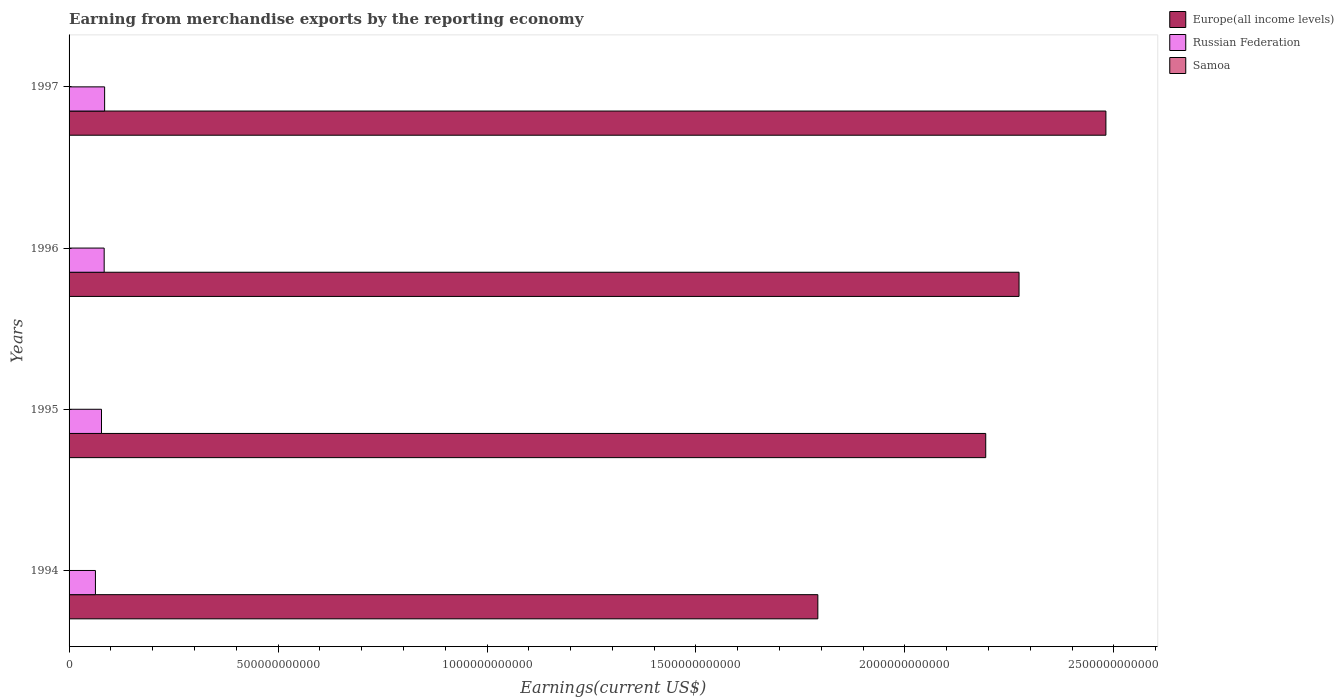How many groups of bars are there?
Give a very brief answer. 4. How many bars are there on the 3rd tick from the bottom?
Offer a terse response. 3. What is the label of the 2nd group of bars from the top?
Give a very brief answer. 1996. In how many cases, is the number of bars for a given year not equal to the number of legend labels?
Make the answer very short. 0. What is the amount earned from merchandise exports in Europe(all income levels) in 1995?
Ensure brevity in your answer.  2.19e+12. Across all years, what is the maximum amount earned from merchandise exports in Samoa?
Ensure brevity in your answer.  6.48e+07. Across all years, what is the minimum amount earned from merchandise exports in Samoa?
Offer a terse response. 3.98e+06. In which year was the amount earned from merchandise exports in Samoa minimum?
Offer a terse response. 1994. What is the total amount earned from merchandise exports in Samoa in the graph?
Your answer should be compact. 1.94e+08. What is the difference between the amount earned from merchandise exports in Russian Federation in 1994 and that in 1997?
Offer a terse response. -2.20e+1. What is the difference between the amount earned from merchandise exports in Europe(all income levels) in 1994 and the amount earned from merchandise exports in Samoa in 1995?
Keep it short and to the point. 1.79e+12. What is the average amount earned from merchandise exports in Russian Federation per year?
Your answer should be compact. 7.74e+1. In the year 1996, what is the difference between the amount earned from merchandise exports in Europe(all income levels) and amount earned from merchandise exports in Russian Federation?
Your response must be concise. 2.19e+12. In how many years, is the amount earned from merchandise exports in Russian Federation greater than 300000000000 US$?
Ensure brevity in your answer.  0. What is the ratio of the amount earned from merchandise exports in Europe(all income levels) in 1994 to that in 1997?
Your answer should be very brief. 0.72. Is the amount earned from merchandise exports in Europe(all income levels) in 1994 less than that in 1995?
Ensure brevity in your answer.  Yes. Is the difference between the amount earned from merchandise exports in Europe(all income levels) in 1995 and 1996 greater than the difference between the amount earned from merchandise exports in Russian Federation in 1995 and 1996?
Your response must be concise. No. What is the difference between the highest and the second highest amount earned from merchandise exports in Samoa?
Give a very brief answer. 6.89e+04. What is the difference between the highest and the lowest amount earned from merchandise exports in Russian Federation?
Ensure brevity in your answer.  2.20e+1. Is the sum of the amount earned from merchandise exports in Samoa in 1994 and 1997 greater than the maximum amount earned from merchandise exports in Europe(all income levels) across all years?
Your answer should be compact. No. What does the 2nd bar from the top in 1995 represents?
Provide a short and direct response. Russian Federation. What does the 3rd bar from the bottom in 1997 represents?
Make the answer very short. Samoa. How many bars are there?
Your answer should be compact. 12. Are all the bars in the graph horizontal?
Keep it short and to the point. Yes. What is the difference between two consecutive major ticks on the X-axis?
Offer a very short reply. 5.00e+11. Are the values on the major ticks of X-axis written in scientific E-notation?
Your answer should be compact. No. Does the graph contain any zero values?
Your response must be concise. No. Where does the legend appear in the graph?
Keep it short and to the point. Top right. How are the legend labels stacked?
Give a very brief answer. Vertical. What is the title of the graph?
Offer a terse response. Earning from merchandise exports by the reporting economy. What is the label or title of the X-axis?
Your answer should be very brief. Earnings(current US$). What is the Earnings(current US$) in Europe(all income levels) in 1994?
Ensure brevity in your answer.  1.79e+12. What is the Earnings(current US$) in Russian Federation in 1994?
Provide a succinct answer. 6.31e+1. What is the Earnings(current US$) of Samoa in 1994?
Your response must be concise. 3.98e+06. What is the Earnings(current US$) of Europe(all income levels) in 1995?
Offer a terse response. 2.19e+12. What is the Earnings(current US$) of Russian Federation in 1995?
Your answer should be very brief. 7.76e+1. What is the Earnings(current US$) of Samoa in 1995?
Your answer should be very brief. 6.09e+07. What is the Earnings(current US$) of Europe(all income levels) in 1996?
Keep it short and to the point. 2.27e+12. What is the Earnings(current US$) of Russian Federation in 1996?
Offer a very short reply. 8.40e+1. What is the Earnings(current US$) of Samoa in 1996?
Keep it short and to the point. 6.48e+07. What is the Earnings(current US$) in Europe(all income levels) in 1997?
Provide a short and direct response. 2.48e+12. What is the Earnings(current US$) in Russian Federation in 1997?
Your response must be concise. 8.51e+1. What is the Earnings(current US$) in Samoa in 1997?
Offer a terse response. 6.47e+07. Across all years, what is the maximum Earnings(current US$) of Europe(all income levels)?
Make the answer very short. 2.48e+12. Across all years, what is the maximum Earnings(current US$) of Russian Federation?
Your answer should be very brief. 8.51e+1. Across all years, what is the maximum Earnings(current US$) of Samoa?
Your response must be concise. 6.48e+07. Across all years, what is the minimum Earnings(current US$) of Europe(all income levels)?
Offer a terse response. 1.79e+12. Across all years, what is the minimum Earnings(current US$) in Russian Federation?
Your answer should be compact. 6.31e+1. Across all years, what is the minimum Earnings(current US$) of Samoa?
Your answer should be compact. 3.98e+06. What is the total Earnings(current US$) of Europe(all income levels) in the graph?
Your answer should be very brief. 8.74e+12. What is the total Earnings(current US$) in Russian Federation in the graph?
Give a very brief answer. 3.10e+11. What is the total Earnings(current US$) in Samoa in the graph?
Provide a succinct answer. 1.94e+08. What is the difference between the Earnings(current US$) of Europe(all income levels) in 1994 and that in 1995?
Make the answer very short. -4.02e+11. What is the difference between the Earnings(current US$) of Russian Federation in 1994 and that in 1995?
Provide a succinct answer. -1.45e+1. What is the difference between the Earnings(current US$) of Samoa in 1994 and that in 1995?
Ensure brevity in your answer.  -5.69e+07. What is the difference between the Earnings(current US$) in Europe(all income levels) in 1994 and that in 1996?
Make the answer very short. -4.81e+11. What is the difference between the Earnings(current US$) of Russian Federation in 1994 and that in 1996?
Your answer should be very brief. -2.09e+1. What is the difference between the Earnings(current US$) of Samoa in 1994 and that in 1996?
Your response must be concise. -6.08e+07. What is the difference between the Earnings(current US$) in Europe(all income levels) in 1994 and that in 1997?
Ensure brevity in your answer.  -6.89e+11. What is the difference between the Earnings(current US$) in Russian Federation in 1994 and that in 1997?
Your answer should be compact. -2.20e+1. What is the difference between the Earnings(current US$) of Samoa in 1994 and that in 1997?
Offer a very short reply. -6.07e+07. What is the difference between the Earnings(current US$) of Europe(all income levels) in 1995 and that in 1996?
Your answer should be very brief. -7.97e+1. What is the difference between the Earnings(current US$) of Russian Federation in 1995 and that in 1996?
Make the answer very short. -6.38e+09. What is the difference between the Earnings(current US$) in Samoa in 1995 and that in 1996?
Provide a short and direct response. -3.85e+06. What is the difference between the Earnings(current US$) in Europe(all income levels) in 1995 and that in 1997?
Ensure brevity in your answer.  -2.88e+11. What is the difference between the Earnings(current US$) of Russian Federation in 1995 and that in 1997?
Your answer should be compact. -7.48e+09. What is the difference between the Earnings(current US$) in Samoa in 1995 and that in 1997?
Provide a short and direct response. -3.79e+06. What is the difference between the Earnings(current US$) of Europe(all income levels) in 1996 and that in 1997?
Keep it short and to the point. -2.08e+11. What is the difference between the Earnings(current US$) of Russian Federation in 1996 and that in 1997?
Keep it short and to the point. -1.10e+09. What is the difference between the Earnings(current US$) of Samoa in 1996 and that in 1997?
Offer a very short reply. 6.89e+04. What is the difference between the Earnings(current US$) of Europe(all income levels) in 1994 and the Earnings(current US$) of Russian Federation in 1995?
Your answer should be very brief. 1.71e+12. What is the difference between the Earnings(current US$) of Europe(all income levels) in 1994 and the Earnings(current US$) of Samoa in 1995?
Offer a terse response. 1.79e+12. What is the difference between the Earnings(current US$) of Russian Federation in 1994 and the Earnings(current US$) of Samoa in 1995?
Your answer should be very brief. 6.30e+1. What is the difference between the Earnings(current US$) of Europe(all income levels) in 1994 and the Earnings(current US$) of Russian Federation in 1996?
Make the answer very short. 1.71e+12. What is the difference between the Earnings(current US$) in Europe(all income levels) in 1994 and the Earnings(current US$) in Samoa in 1996?
Your answer should be compact. 1.79e+12. What is the difference between the Earnings(current US$) in Russian Federation in 1994 and the Earnings(current US$) in Samoa in 1996?
Offer a terse response. 6.30e+1. What is the difference between the Earnings(current US$) of Europe(all income levels) in 1994 and the Earnings(current US$) of Russian Federation in 1997?
Ensure brevity in your answer.  1.71e+12. What is the difference between the Earnings(current US$) in Europe(all income levels) in 1994 and the Earnings(current US$) in Samoa in 1997?
Your answer should be very brief. 1.79e+12. What is the difference between the Earnings(current US$) in Russian Federation in 1994 and the Earnings(current US$) in Samoa in 1997?
Your answer should be very brief. 6.30e+1. What is the difference between the Earnings(current US$) of Europe(all income levels) in 1995 and the Earnings(current US$) of Russian Federation in 1996?
Your response must be concise. 2.11e+12. What is the difference between the Earnings(current US$) of Europe(all income levels) in 1995 and the Earnings(current US$) of Samoa in 1996?
Provide a succinct answer. 2.19e+12. What is the difference between the Earnings(current US$) in Russian Federation in 1995 and the Earnings(current US$) in Samoa in 1996?
Your answer should be compact. 7.75e+1. What is the difference between the Earnings(current US$) of Europe(all income levels) in 1995 and the Earnings(current US$) of Russian Federation in 1997?
Offer a terse response. 2.11e+12. What is the difference between the Earnings(current US$) of Europe(all income levels) in 1995 and the Earnings(current US$) of Samoa in 1997?
Offer a terse response. 2.19e+12. What is the difference between the Earnings(current US$) in Russian Federation in 1995 and the Earnings(current US$) in Samoa in 1997?
Ensure brevity in your answer.  7.75e+1. What is the difference between the Earnings(current US$) in Europe(all income levels) in 1996 and the Earnings(current US$) in Russian Federation in 1997?
Provide a succinct answer. 2.19e+12. What is the difference between the Earnings(current US$) of Europe(all income levels) in 1996 and the Earnings(current US$) of Samoa in 1997?
Provide a short and direct response. 2.27e+12. What is the difference between the Earnings(current US$) of Russian Federation in 1996 and the Earnings(current US$) of Samoa in 1997?
Make the answer very short. 8.39e+1. What is the average Earnings(current US$) of Europe(all income levels) per year?
Offer a terse response. 2.18e+12. What is the average Earnings(current US$) of Russian Federation per year?
Offer a very short reply. 7.74e+1. What is the average Earnings(current US$) in Samoa per year?
Ensure brevity in your answer.  4.86e+07. In the year 1994, what is the difference between the Earnings(current US$) in Europe(all income levels) and Earnings(current US$) in Russian Federation?
Your answer should be compact. 1.73e+12. In the year 1994, what is the difference between the Earnings(current US$) in Europe(all income levels) and Earnings(current US$) in Samoa?
Make the answer very short. 1.79e+12. In the year 1994, what is the difference between the Earnings(current US$) of Russian Federation and Earnings(current US$) of Samoa?
Keep it short and to the point. 6.31e+1. In the year 1995, what is the difference between the Earnings(current US$) of Europe(all income levels) and Earnings(current US$) of Russian Federation?
Keep it short and to the point. 2.12e+12. In the year 1995, what is the difference between the Earnings(current US$) of Europe(all income levels) and Earnings(current US$) of Samoa?
Your response must be concise. 2.19e+12. In the year 1995, what is the difference between the Earnings(current US$) in Russian Federation and Earnings(current US$) in Samoa?
Offer a terse response. 7.75e+1. In the year 1996, what is the difference between the Earnings(current US$) of Europe(all income levels) and Earnings(current US$) of Russian Federation?
Your answer should be very brief. 2.19e+12. In the year 1996, what is the difference between the Earnings(current US$) in Europe(all income levels) and Earnings(current US$) in Samoa?
Give a very brief answer. 2.27e+12. In the year 1996, what is the difference between the Earnings(current US$) of Russian Federation and Earnings(current US$) of Samoa?
Make the answer very short. 8.39e+1. In the year 1997, what is the difference between the Earnings(current US$) in Europe(all income levels) and Earnings(current US$) in Russian Federation?
Your response must be concise. 2.40e+12. In the year 1997, what is the difference between the Earnings(current US$) of Europe(all income levels) and Earnings(current US$) of Samoa?
Keep it short and to the point. 2.48e+12. In the year 1997, what is the difference between the Earnings(current US$) in Russian Federation and Earnings(current US$) in Samoa?
Keep it short and to the point. 8.50e+1. What is the ratio of the Earnings(current US$) in Europe(all income levels) in 1994 to that in 1995?
Provide a short and direct response. 0.82. What is the ratio of the Earnings(current US$) in Russian Federation in 1994 to that in 1995?
Your response must be concise. 0.81. What is the ratio of the Earnings(current US$) in Samoa in 1994 to that in 1995?
Keep it short and to the point. 0.07. What is the ratio of the Earnings(current US$) of Europe(all income levels) in 1994 to that in 1996?
Provide a succinct answer. 0.79. What is the ratio of the Earnings(current US$) in Russian Federation in 1994 to that in 1996?
Offer a terse response. 0.75. What is the ratio of the Earnings(current US$) in Samoa in 1994 to that in 1996?
Your answer should be very brief. 0.06. What is the ratio of the Earnings(current US$) in Europe(all income levels) in 1994 to that in 1997?
Ensure brevity in your answer.  0.72. What is the ratio of the Earnings(current US$) of Russian Federation in 1994 to that in 1997?
Provide a succinct answer. 0.74. What is the ratio of the Earnings(current US$) in Samoa in 1994 to that in 1997?
Offer a very short reply. 0.06. What is the ratio of the Earnings(current US$) of Europe(all income levels) in 1995 to that in 1996?
Offer a very short reply. 0.96. What is the ratio of the Earnings(current US$) in Russian Federation in 1995 to that in 1996?
Your response must be concise. 0.92. What is the ratio of the Earnings(current US$) in Samoa in 1995 to that in 1996?
Offer a terse response. 0.94. What is the ratio of the Earnings(current US$) of Europe(all income levels) in 1995 to that in 1997?
Offer a terse response. 0.88. What is the ratio of the Earnings(current US$) in Russian Federation in 1995 to that in 1997?
Keep it short and to the point. 0.91. What is the ratio of the Earnings(current US$) in Samoa in 1995 to that in 1997?
Offer a very short reply. 0.94. What is the ratio of the Earnings(current US$) of Europe(all income levels) in 1996 to that in 1997?
Offer a very short reply. 0.92. What is the ratio of the Earnings(current US$) in Russian Federation in 1996 to that in 1997?
Offer a terse response. 0.99. What is the ratio of the Earnings(current US$) of Samoa in 1996 to that in 1997?
Ensure brevity in your answer.  1. What is the difference between the highest and the second highest Earnings(current US$) of Europe(all income levels)?
Make the answer very short. 2.08e+11. What is the difference between the highest and the second highest Earnings(current US$) of Russian Federation?
Provide a succinct answer. 1.10e+09. What is the difference between the highest and the second highest Earnings(current US$) of Samoa?
Provide a short and direct response. 6.89e+04. What is the difference between the highest and the lowest Earnings(current US$) of Europe(all income levels)?
Offer a terse response. 6.89e+11. What is the difference between the highest and the lowest Earnings(current US$) of Russian Federation?
Your answer should be compact. 2.20e+1. What is the difference between the highest and the lowest Earnings(current US$) of Samoa?
Provide a succinct answer. 6.08e+07. 